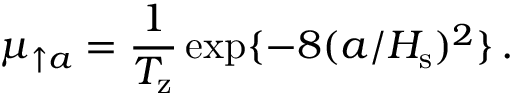Convert formula to latex. <formula><loc_0><loc_0><loc_500><loc_500>\mu _ { \uparrow a } = \frac { 1 } { T _ { z } } \exp \{ - 8 ( a / H _ { s } ) ^ { 2 } \} \, .</formula> 